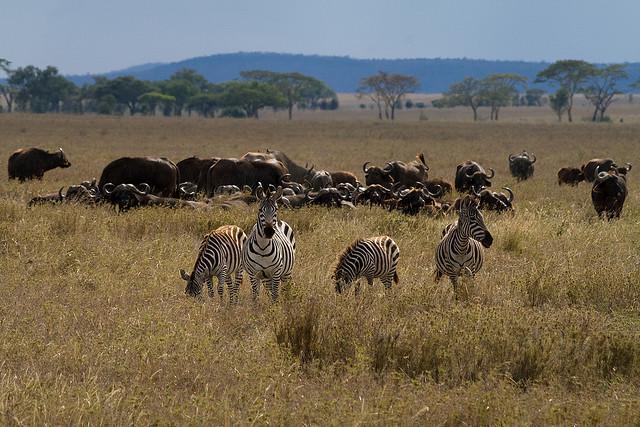How many zebras?
Give a very brief answer. 4. How many different types of animals do you see?
Give a very brief answer. 2. How many cows are there?
Give a very brief answer. 2. How many zebras are there?
Give a very brief answer. 4. 